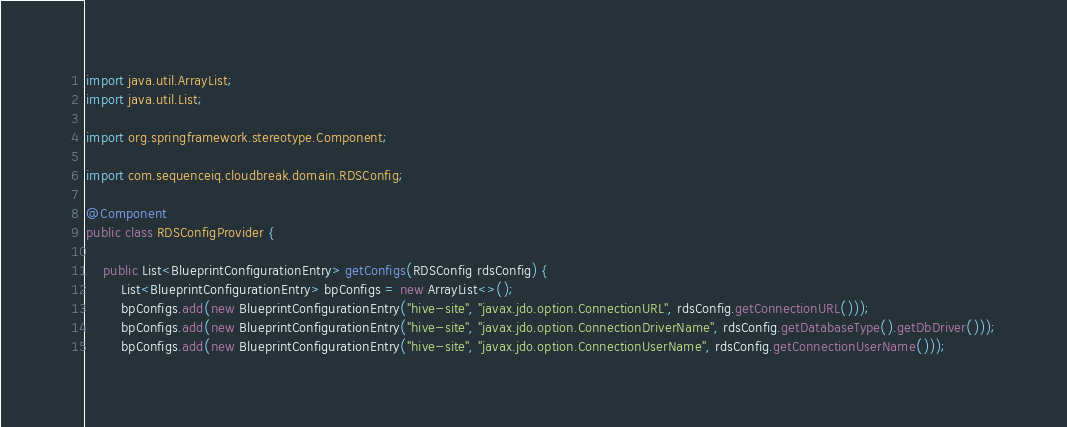<code> <loc_0><loc_0><loc_500><loc_500><_Java_>import java.util.ArrayList;
import java.util.List;

import org.springframework.stereotype.Component;

import com.sequenceiq.cloudbreak.domain.RDSConfig;

@Component
public class RDSConfigProvider {

    public List<BlueprintConfigurationEntry> getConfigs(RDSConfig rdsConfig) {
        List<BlueprintConfigurationEntry> bpConfigs = new ArrayList<>();
        bpConfigs.add(new BlueprintConfigurationEntry("hive-site", "javax.jdo.option.ConnectionURL", rdsConfig.getConnectionURL()));
        bpConfigs.add(new BlueprintConfigurationEntry("hive-site", "javax.jdo.option.ConnectionDriverName", rdsConfig.getDatabaseType().getDbDriver()));
        bpConfigs.add(new BlueprintConfigurationEntry("hive-site", "javax.jdo.option.ConnectionUserName", rdsConfig.getConnectionUserName()));</code> 